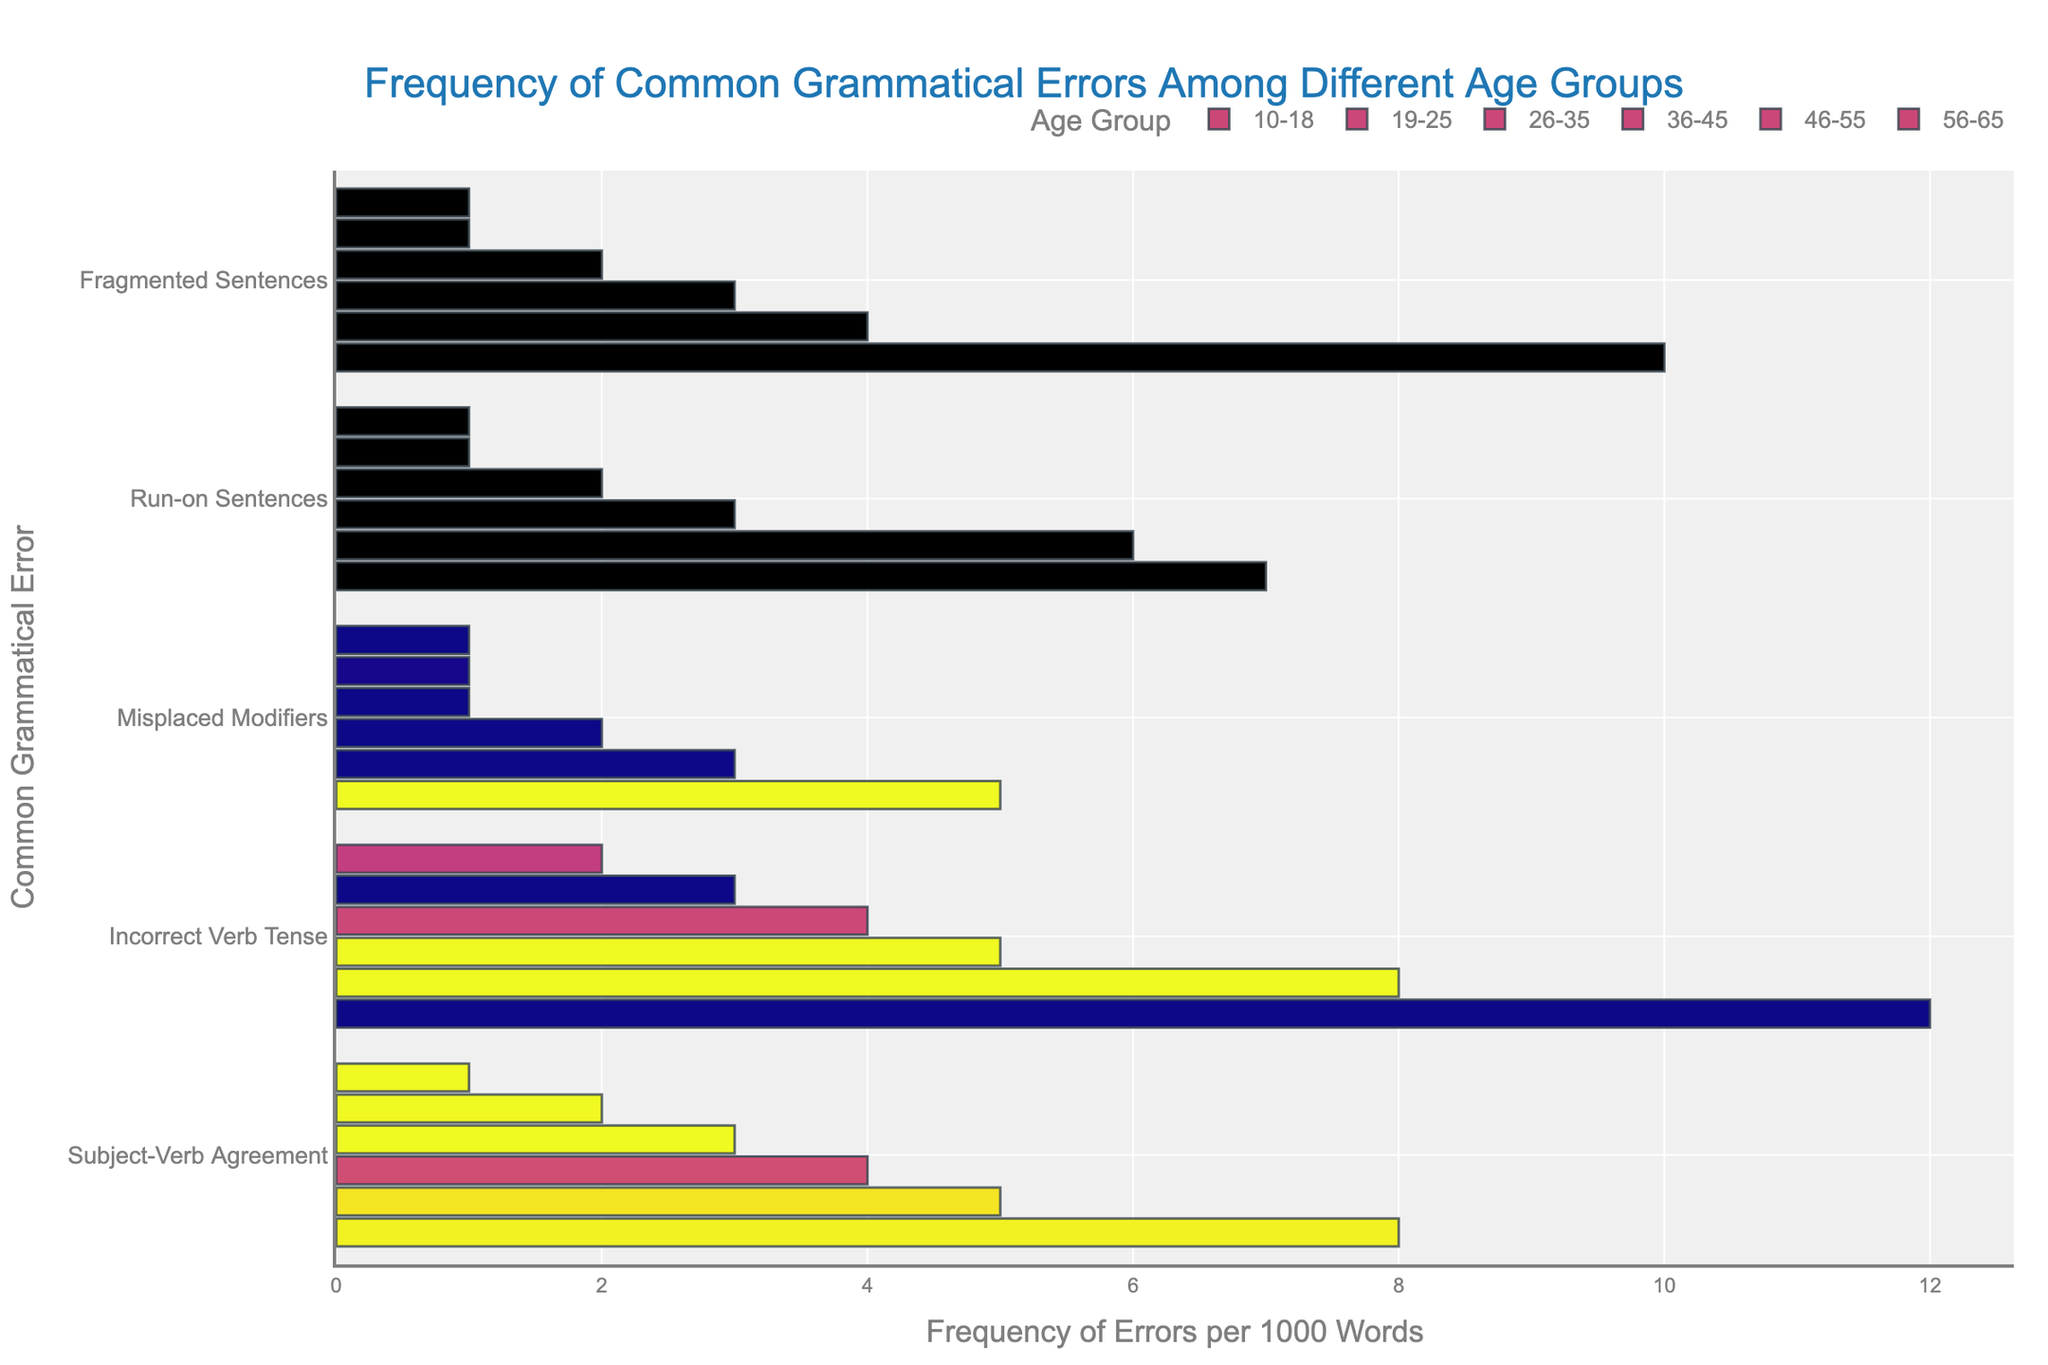Which age group has the highest frequency of grammatical errors overall? By visually assessing the cumulative heights of the bars for each age group, the 10-18 age group consistently shows higher bars for all error types compared to other age groups.
Answer: 10-18 Which type of grammatical error has the highest frequency in the 19-25 age group? By identifying the tallest bar in the 19-25 age group, it is the bar representing "Incorrect Verb Tense" that stands out.
Answer: Incorrect Verb Tense What is the difference in the frequency of Subject-Verb Agreement errors between the 10-18 age group and the 56-65 age group? The bar representing Subject-Verb Agreement for the 10-18 age group is at 8, whereas for the 56-65 age group, it is at 1. Subtract 1 from 8 to find the difference.
Answer: 7 Which has more frequent use of Misplaced Modifiers: the 36-45 age group or the 46-55 age group? Comparing the bar lengths, the 36-45 age group has a bar length of 1 while the 46-55 age group has a bar length of 1 as well.
Answer: Equal What is the sum of the frequency of all grammatical errors for the 26-35 age group? Summing the values of the corresponding bars: 4 (Subject-Verb Agreement) + 5 (Incorrect Verb Tense) + 2 (Misplaced Modifiers) + 3 (Run-on Sentences) + 3 (Fragmented Sentences). 4 + 5 + 2 + 3 + 3 = 17.
Answer: 17 What is the average frequency of Run-on Sentences errors across all age groups? Add up all the frequencies for Run-on Sentences: 7 (10-18) + 6 (19-25) + 3 (26-35) + 2 (36-45) + 1 (46-55) + 1 (56-65). The sum is 20. Since there are 6 age groups, the average is 20/6 ≈ 3.33.
Answer: 3.33 Which age group shows the least frequent grammatical errors for Fragmented Sentences? By visually finding the shortest bar for Fragmented Sentences, we see it's the same minimal height for both the 46-55 and 56-65 age groups.
Answer: 46-55 and 56-65 What is the combined frequency of Misplaced Modifiers and Fragmented Sentences errors for the 19-25 age group? Adding the individual frequencies: 3 (Misplaced Modifiers) + 4 (Fragmented Sentences). 3 + 4 = 7.
Answer: 7 Which grammatical error type has the most even distribution of errors across all age groups? By visually scanning the chart, the bars for Subject-Verb Agreement are relatively evenly distributed with less variance compared to other errors.
Answer: Subject-Verb Agreement How does the frequency of Incorrect Verb Tense errors in the 36-45 age group compare to those in the 26-35 age group? The bar lengths for Incorrect Verb Tense are 4 for the 36-45 age group and 5 for the 26-35 age group.
Answer: Less 